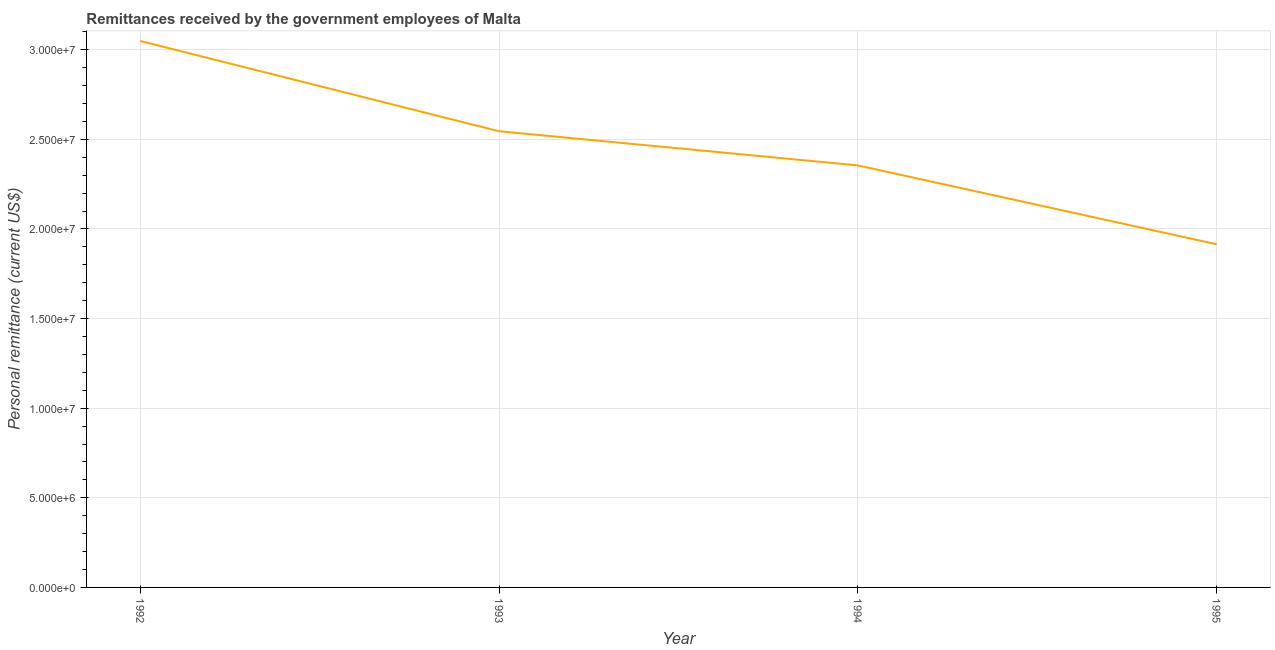What is the personal remittances in 1992?
Keep it short and to the point. 3.05e+07. Across all years, what is the maximum personal remittances?
Your response must be concise. 3.05e+07. Across all years, what is the minimum personal remittances?
Provide a short and direct response. 1.91e+07. In which year was the personal remittances maximum?
Give a very brief answer. 1992. What is the sum of the personal remittances?
Offer a very short reply. 9.86e+07. What is the difference between the personal remittances in 1992 and 1994?
Your response must be concise. 6.94e+06. What is the average personal remittances per year?
Your response must be concise. 2.47e+07. What is the median personal remittances?
Your response must be concise. 2.45e+07. What is the ratio of the personal remittances in 1992 to that in 1993?
Offer a terse response. 1.2. Is the personal remittances in 1992 less than that in 1993?
Your answer should be compact. No. Is the difference between the personal remittances in 1992 and 1993 greater than the difference between any two years?
Ensure brevity in your answer.  No. What is the difference between the highest and the second highest personal remittances?
Offer a very short reply. 5.04e+06. Is the sum of the personal remittances in 1992 and 1994 greater than the maximum personal remittances across all years?
Provide a short and direct response. Yes. What is the difference between the highest and the lowest personal remittances?
Offer a terse response. 1.13e+07. In how many years, is the personal remittances greater than the average personal remittances taken over all years?
Your answer should be very brief. 2. What is the difference between two consecutive major ticks on the Y-axis?
Provide a short and direct response. 5.00e+06. What is the title of the graph?
Give a very brief answer. Remittances received by the government employees of Malta. What is the label or title of the Y-axis?
Keep it short and to the point. Personal remittance (current US$). What is the Personal remittance (current US$) of 1992?
Give a very brief answer. 3.05e+07. What is the Personal remittance (current US$) of 1993?
Ensure brevity in your answer.  2.55e+07. What is the Personal remittance (current US$) in 1994?
Make the answer very short. 2.35e+07. What is the Personal remittance (current US$) of 1995?
Give a very brief answer. 1.91e+07. What is the difference between the Personal remittance (current US$) in 1992 and 1993?
Keep it short and to the point. 5.04e+06. What is the difference between the Personal remittance (current US$) in 1992 and 1994?
Make the answer very short. 6.94e+06. What is the difference between the Personal remittance (current US$) in 1992 and 1995?
Offer a terse response. 1.13e+07. What is the difference between the Personal remittance (current US$) in 1993 and 1994?
Provide a succinct answer. 1.91e+06. What is the difference between the Personal remittance (current US$) in 1993 and 1995?
Make the answer very short. 6.31e+06. What is the difference between the Personal remittance (current US$) in 1994 and 1995?
Your answer should be very brief. 4.40e+06. What is the ratio of the Personal remittance (current US$) in 1992 to that in 1993?
Ensure brevity in your answer.  1.2. What is the ratio of the Personal remittance (current US$) in 1992 to that in 1994?
Make the answer very short. 1.29. What is the ratio of the Personal remittance (current US$) in 1992 to that in 1995?
Ensure brevity in your answer.  1.59. What is the ratio of the Personal remittance (current US$) in 1993 to that in 1994?
Offer a terse response. 1.08. What is the ratio of the Personal remittance (current US$) in 1993 to that in 1995?
Offer a very short reply. 1.33. What is the ratio of the Personal remittance (current US$) in 1994 to that in 1995?
Ensure brevity in your answer.  1.23. 